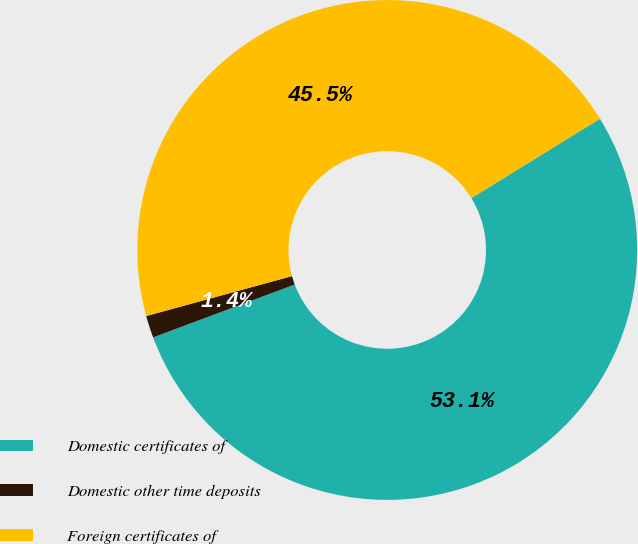<chart> <loc_0><loc_0><loc_500><loc_500><pie_chart><fcel>Domestic certificates of<fcel>Domestic other time deposits<fcel>Foreign certificates of<nl><fcel>53.11%<fcel>1.43%<fcel>45.46%<nl></chart> 